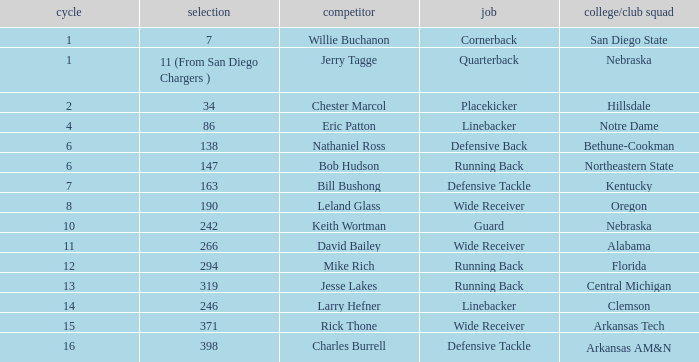In which round does the position of cornerback occur? 1.0. Parse the table in full. {'header': ['cycle', 'selection', 'competitor', 'job', 'college/club squad'], 'rows': [['1', '7', 'Willie Buchanon', 'Cornerback', 'San Diego State'], ['1', '11 (From San Diego Chargers )', 'Jerry Tagge', 'Quarterback', 'Nebraska'], ['2', '34', 'Chester Marcol', 'Placekicker', 'Hillsdale'], ['4', '86', 'Eric Patton', 'Linebacker', 'Notre Dame'], ['6', '138', 'Nathaniel Ross', 'Defensive Back', 'Bethune-Cookman'], ['6', '147', 'Bob Hudson', 'Running Back', 'Northeastern State'], ['7', '163', 'Bill Bushong', 'Defensive Tackle', 'Kentucky'], ['8', '190', 'Leland Glass', 'Wide Receiver', 'Oregon'], ['10', '242', 'Keith Wortman', 'Guard', 'Nebraska'], ['11', '266', 'David Bailey', 'Wide Receiver', 'Alabama'], ['12', '294', 'Mike Rich', 'Running Back', 'Florida'], ['13', '319', 'Jesse Lakes', 'Running Back', 'Central Michigan'], ['14', '246', 'Larry Hefner', 'Linebacker', 'Clemson'], ['15', '371', 'Rick Thone', 'Wide Receiver', 'Arkansas Tech'], ['16', '398', 'Charles Burrell', 'Defensive Tackle', 'Arkansas AM&N']]} 